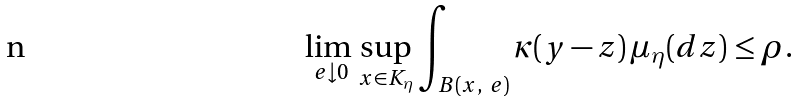Convert formula to latex. <formula><loc_0><loc_0><loc_500><loc_500>\lim _ { \ e \downarrow 0 } \, \sup _ { x \in K _ { \eta } } \int _ { B ( x , \ e ) } \kappa ( y - z ) \, \mu _ { \eta } ( d z ) \leq \rho .</formula> 